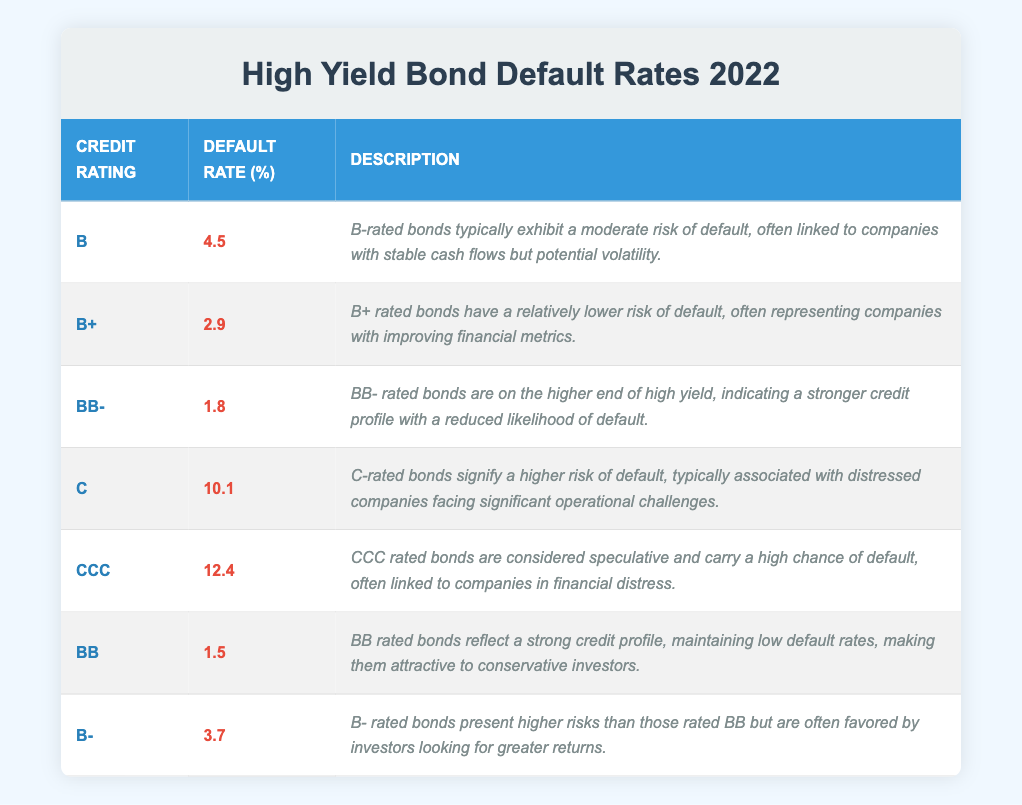What is the default rate for BB rated bonds? The table states that the default rate for BB rated bonds is 1.5%. This value can be found directly under the "Default Rate (%)" column corresponding to the "BB" credit rating.
Answer: 1.5% Which credit rating has the highest default rate? By examining the "Default Rate (%)" column, it can be identified that CCC rated bonds have the highest default rate, which is 12.4%. This is higher than all other credit ratings listed in the table.
Answer: CCC What is the average default rate of bonds rated B and B+? The default rates for B and B+ rated bonds are 4.5% and 2.9%, respectively. To find the average, sum these two rates (4.5 + 2.9 = 7.4) and divide by 2 (7.4 / 2 = 3.7).
Answer: 3.7 Is the default rate for BB rated bonds lower than that of B rated bonds? The default rate for BB rated bonds is 1.5%, and for B rated bonds it is 4.5%. Since 1.5% is less than 4.5%, the statement is true.
Answer: Yes What is the difference in default rates between C and CCC rated bonds? The default rate for C rated bonds is 10.1% and for CCC rated bonds it is 12.4%. To find the difference, subtract the default rate for C from that for CCC (12.4 - 10.1 = 2.3), indicating that CCC rated bonds have 2.3% higher default rates than C rated bonds.
Answer: 2.3 